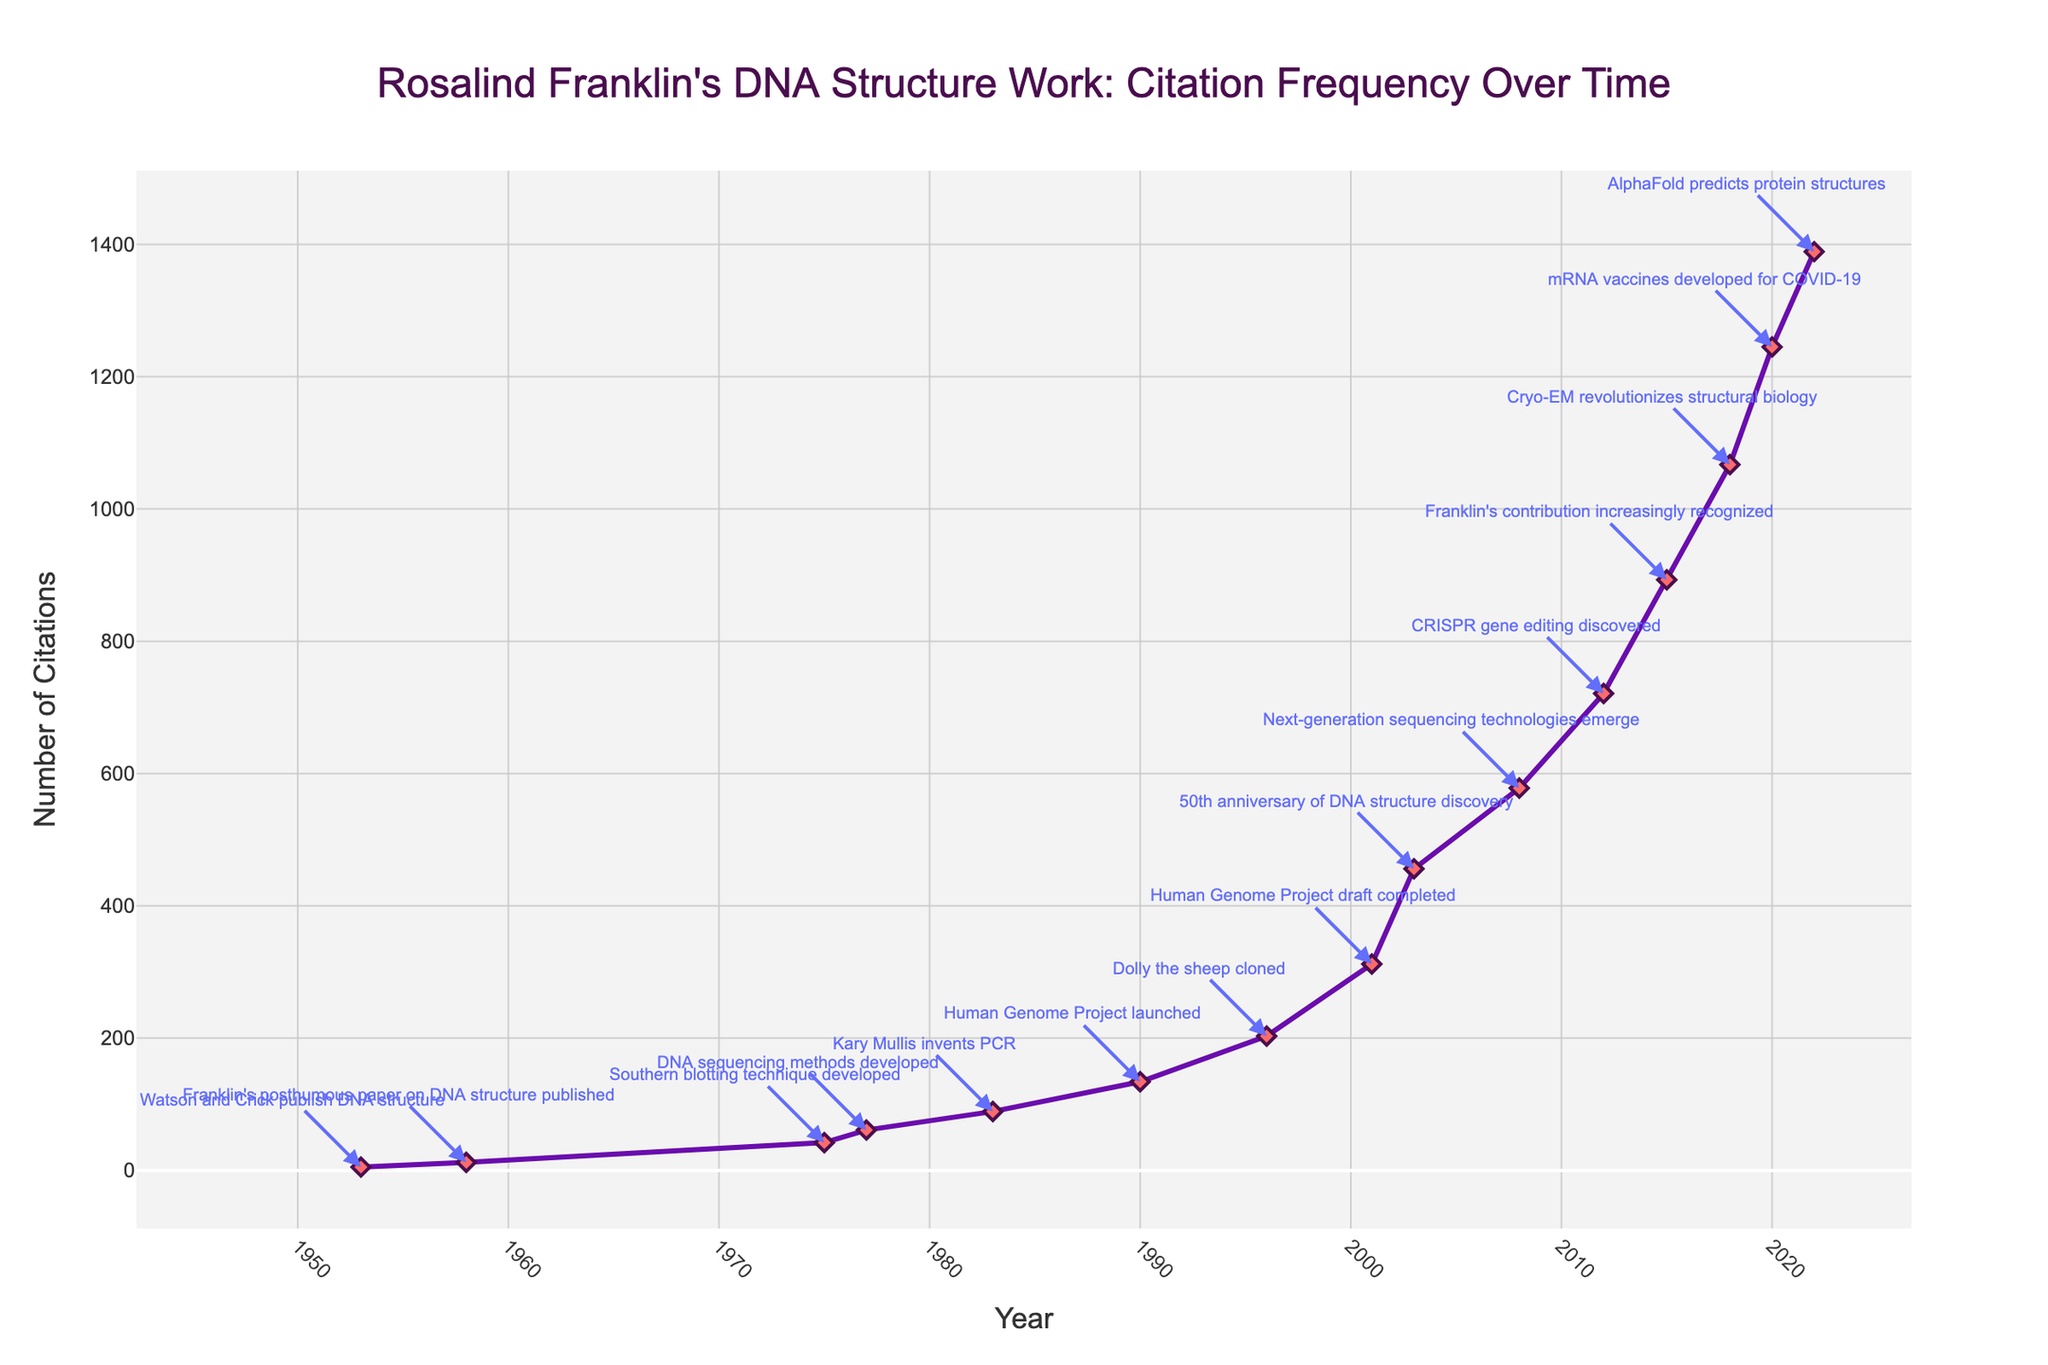What year had the highest frequency of citations for Franklin's work? The highest frequency of citations is 1389, which occurs in the year 2022.
Answer: 2022 Between 1953 and 2022, which milestone corresponds with the largest increase in citations? Compare the citations at each milestone and find the largest difference: Human Genome Project draft completion in 2001 (312 citations) followed by the 50th anniversary of DNA structure discovery in 2003 (456 citations) gives an increase of 144 citations.
Answer: 50th anniversary of DNA structure discovery Which milestone year shows the first major increase in citations? The first noticeable increase in citations is between 1958 and 1975, corresponding to the milestone of Southern blotting technique development in 1975, increasing from 12 to 42 citations.
Answer: Southern blotting technique developed What is the trend in citations after 2015 until 2022? From 2015 to 2022, the citations consistently increase each year: 2015 (893), 2018 (1067), 2020 (1245), and 2022 (1389). This indicates a clear upward trend in citations over these years.
Answer: Upward trend Compare the number of citations in the year Dolly the sheep was cloned versus the year the Human Genome Project draft was completed. In 1996 (Dolly the sheep cloned), there were 203 citations, and in 2001 (Human Genome Project draft completed), there were 312 citations. 312 - 203 shows an increase of 109 citations.
Answer: 109 Which milestone appears to have the most significant citation growth immediately following its occurrence? After CRISPR gene editing discovered in 2012, there is a significant jump from 721 citations in 2012 to 893 in 2015, showing a growth of 172 citations.
Answer: CRISPR gene editing discovered How many citations were there on the 50th anniversary of the DNA structure discovery compared to when next-generation sequencing technologies emerged? In 2003 (50th anniversary), there were 456 citations, and in 2008 (next-gen sequencing), there were 578 citations. 578 - 456 shows an increase of 122 citations.
Answer: 122 Based on the figure, which milestone coincides with a notable increase in citations in the 1980s? The notable increase in the 1980s corresponds to Kary Mullis inventing PCR in 1983, increasing from 61 citations in 1977 to 89 citations in 1983.
Answer: Kary Mullis invents PCR What visual cues indicate milestone events on the chart? Milestone events are indicated by labeled text annotations with arrows pointing to the relevant data points on the line chart, illustrating key achievements in molecular biology.
Answer: Labeled text annotations with arrows What can be inferred about the recognition of Franklin’s contributions around 2015? The citation frequency increases significantly around 2015, which is highlighted as the year Rosalind Franklin's contributions were increasingly recognized, indicating growing acknowledgment of her work.
Answer: Growing acknowledgment 